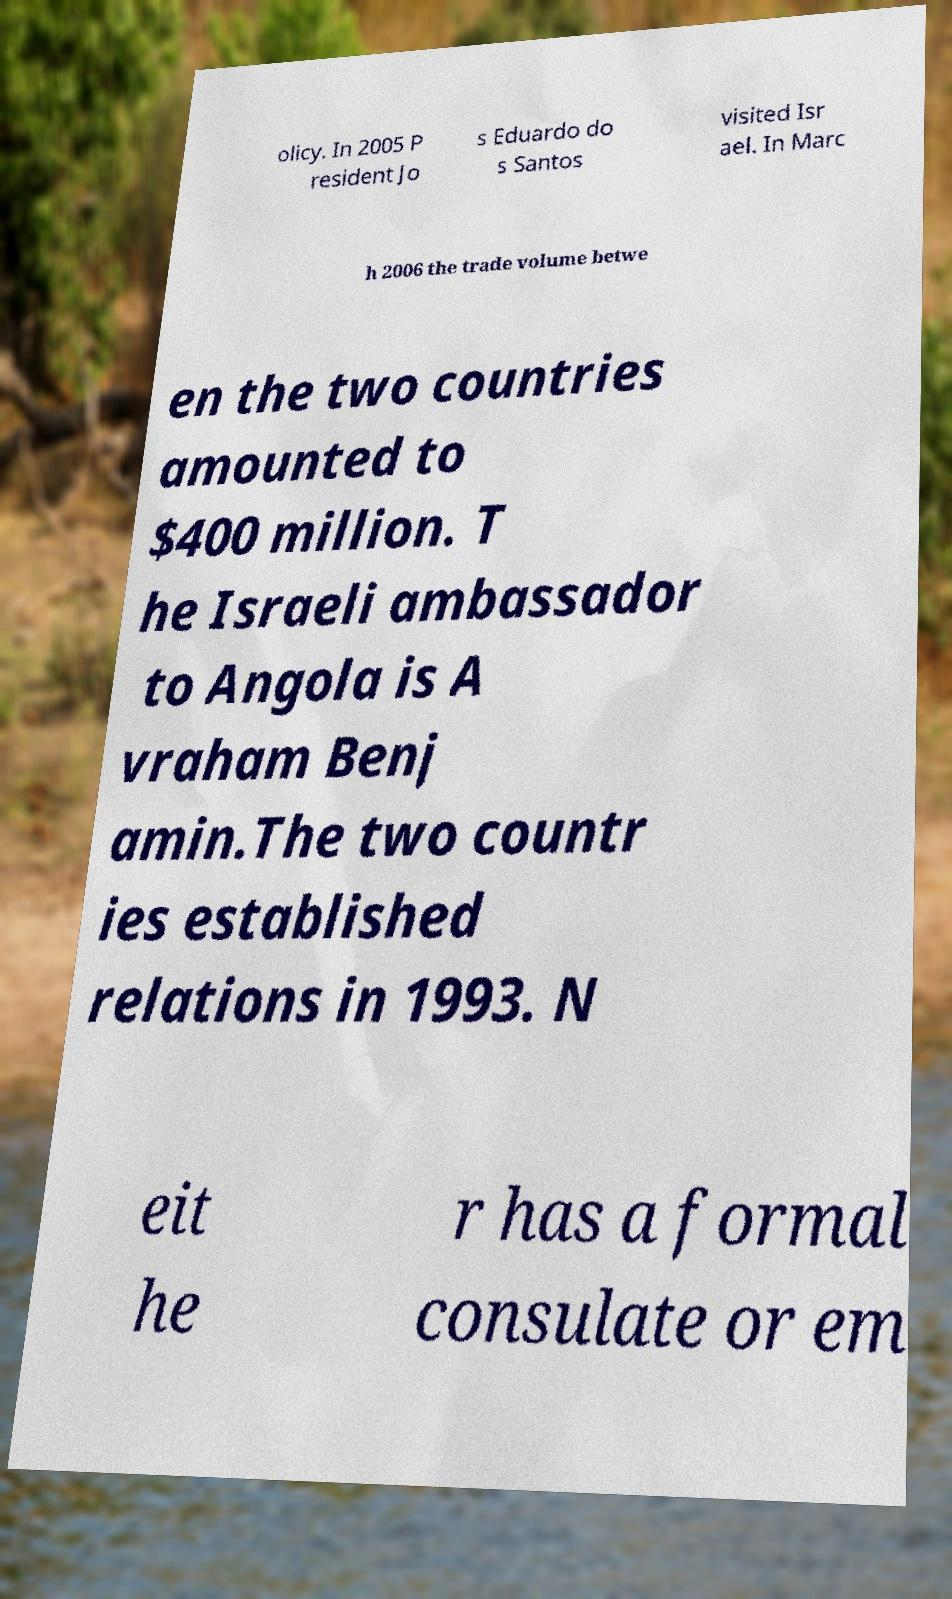Could you assist in decoding the text presented in this image and type it out clearly? olicy. In 2005 P resident Jo s Eduardo do s Santos visited Isr ael. In Marc h 2006 the trade volume betwe en the two countries amounted to $400 million. T he Israeli ambassador to Angola is A vraham Benj amin.The two countr ies established relations in 1993. N eit he r has a formal consulate or em 